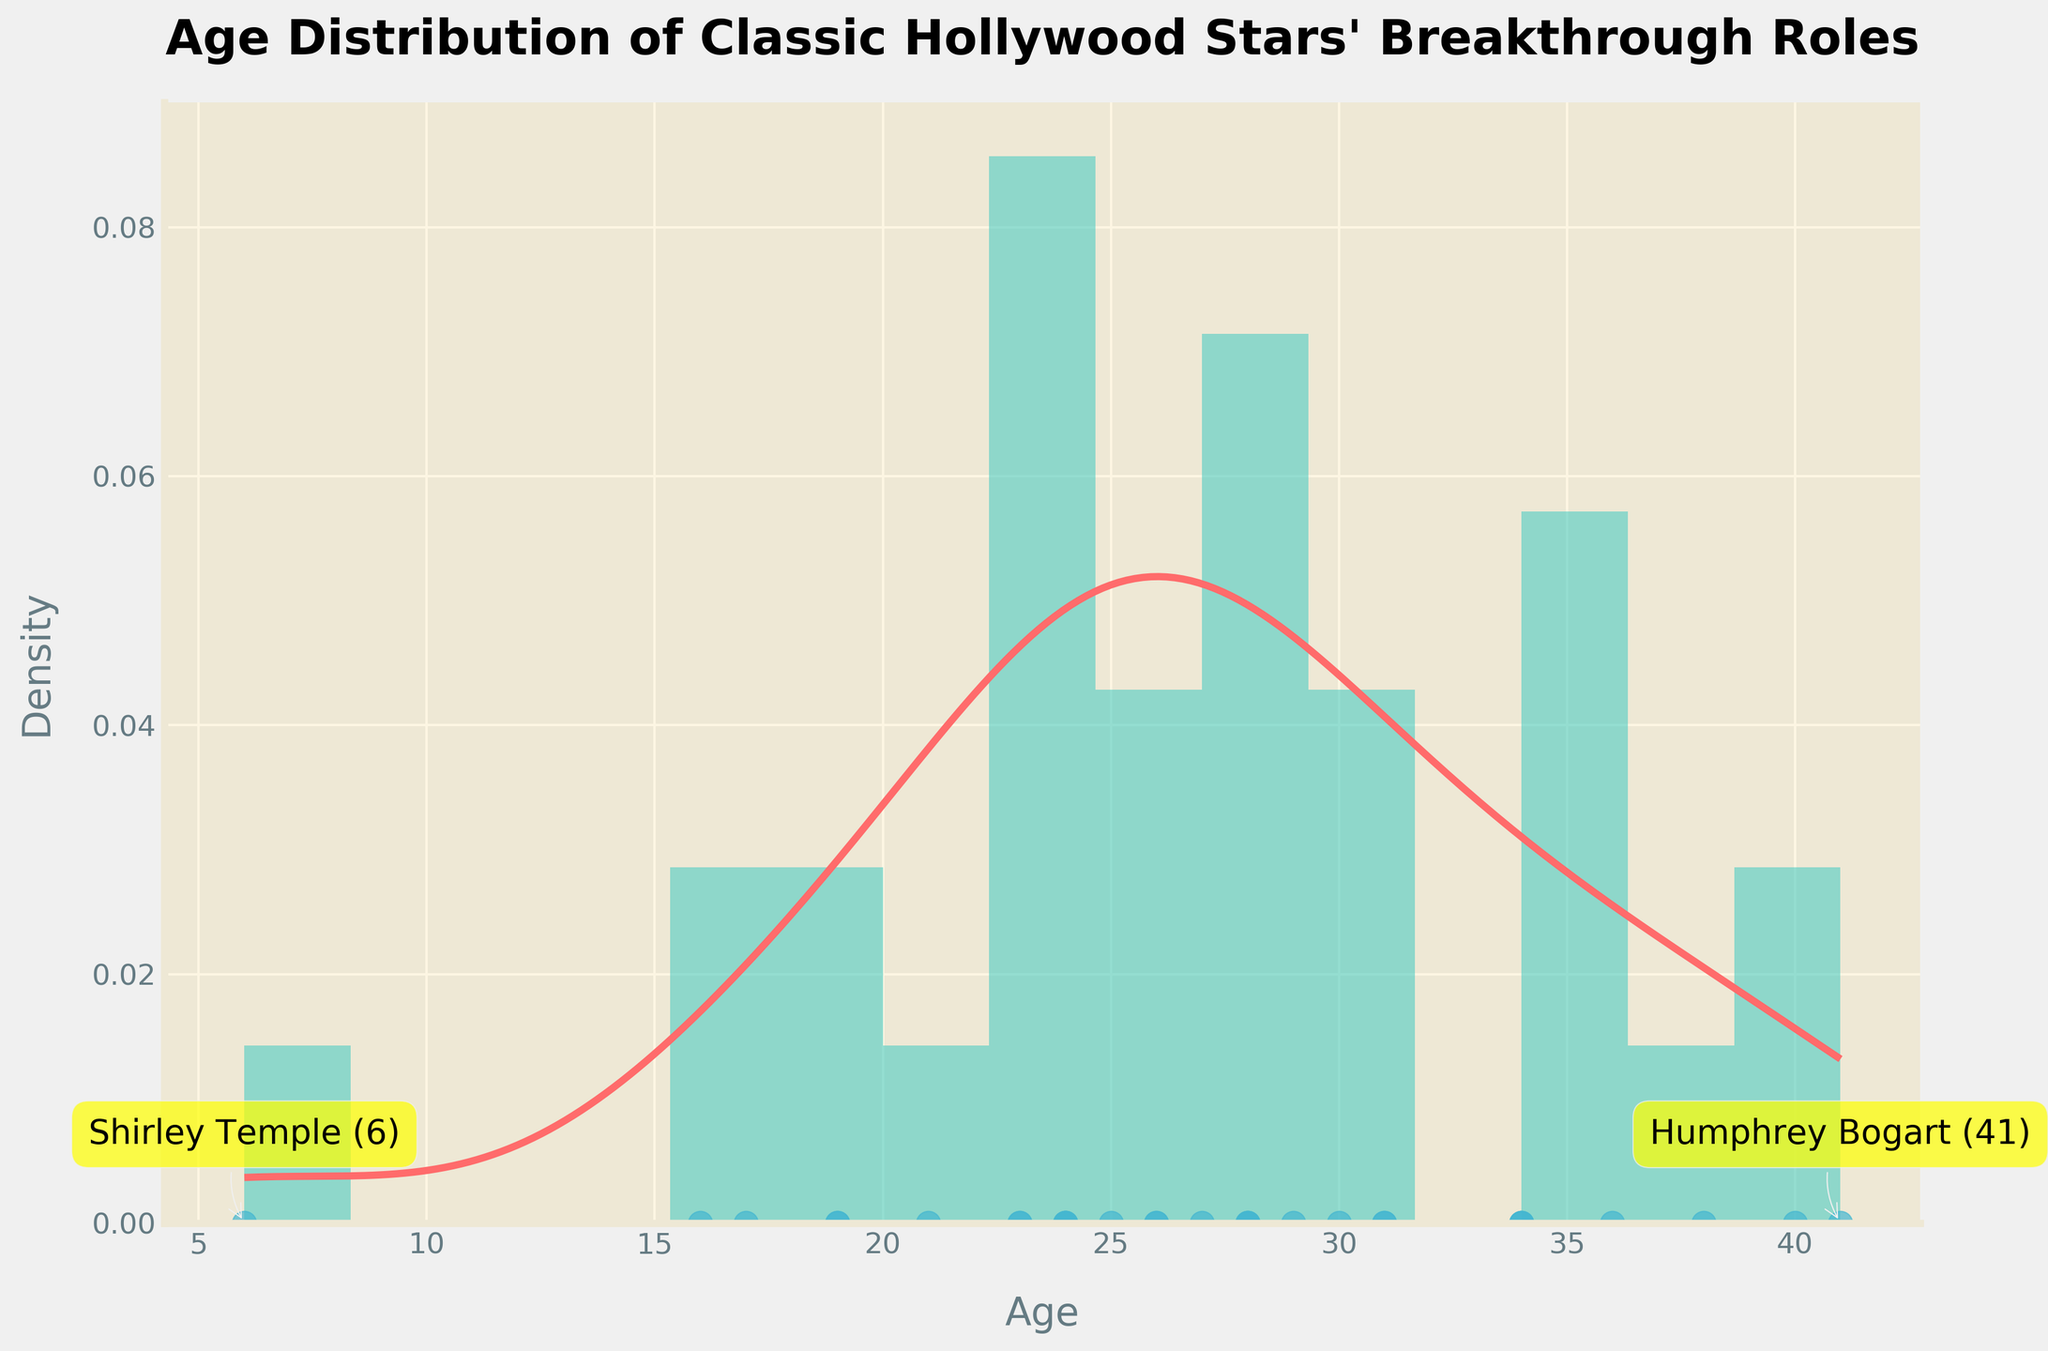What's the title of the plot? The title is displayed at the top of the figure in a large font. It summarizes the content of the plot.
Answer: Age Distribution of Classic Hollywood Stars' Breakthrough Roles What are the colors used for the density plot, histogram, and scatter plot? The colors are visually distinct and are used to differentiate between the plot elements. The density plot is red, the histogram is green, and the scatter plot is blue.
Answer: Red, Green, Blue What is the minimum age at which a star had their breakthrough role? To find the minimum age, look at the smallest value on the x-axis with a corresponding scatter plot point.
Answer: 6 How many stars had their breakthrough roles by the age of 25? To determine the number of stars, count the scatter plot points up to the age of 25.
Answer: 12 Which actor had their breakthrough role at the age of 41? Look for text annotations on the plot that indicate specific names and ages.
Answer: Humphrey Bogart What is the approximate peak density of the age distribution? To determine the peak density, find the highest point on the density plot line (red curve).
Answer: Around 0.03 How does the density change from age 20 to age 30? Observe the red curve from age 20 to age 30, noting the shape, increasing trends, and peaks. The trend shows a rise and falls, peaking between mid-20s.
Answer: Increasing, peaks around mid-20s, then decreases Which age has the highest number of actors having their breakthrough roles according to the histogram? Look at the tallest bar in the histogram to identify which age group it corresponds to.
Answer: 24 What age range has the lowest density of actor breakthrough roles? Locate the section of the red density plot that is lowest compared to the other sections, likely around the edges.
Answer: Around 35-40 Compared to the youngest actor (age 6), how much older was the oldest actor at their breakthrough role? Subtract the youngest age from the oldest age visible in the scatter plot.
Answer: 41 - 6 = 35 years older 